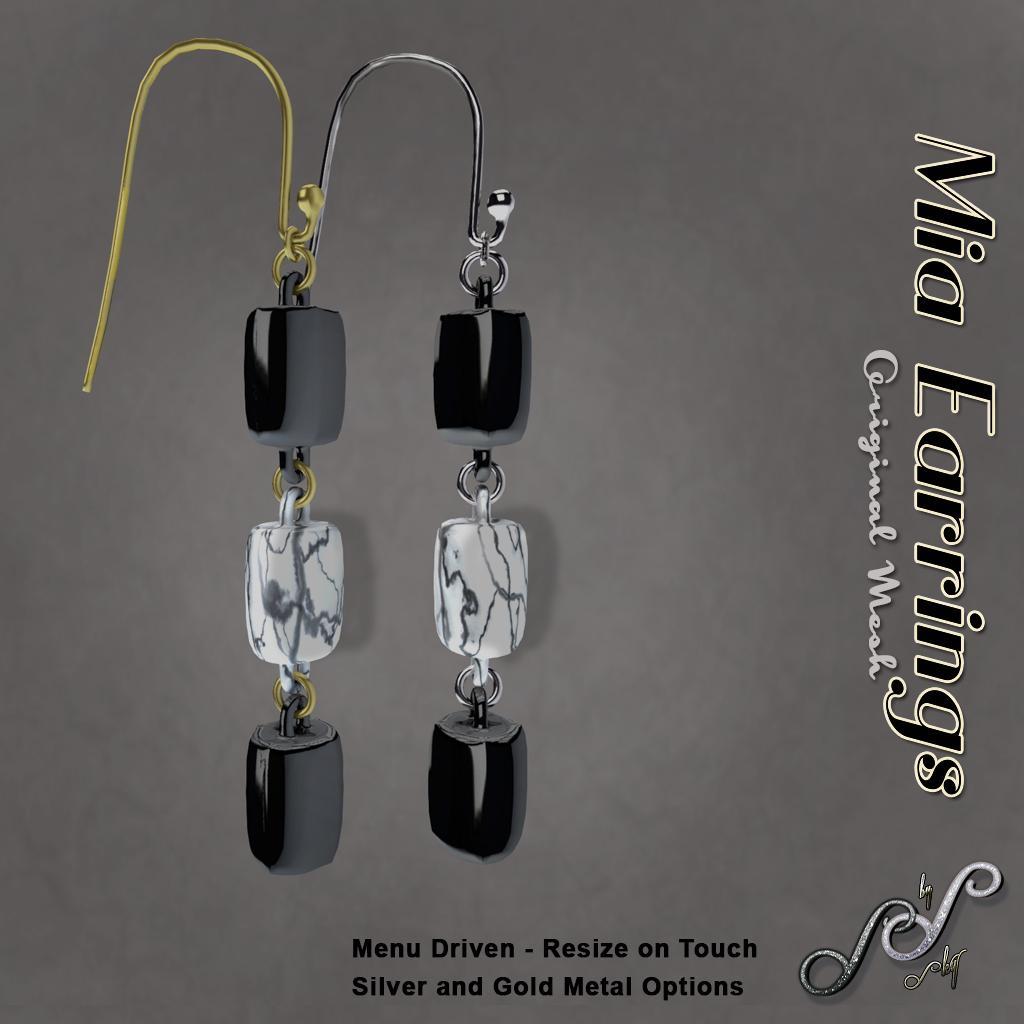Describe this image in one or two sentences. This is a picture of a poster and we can see some information. In this picture we can see pair of earrings. 